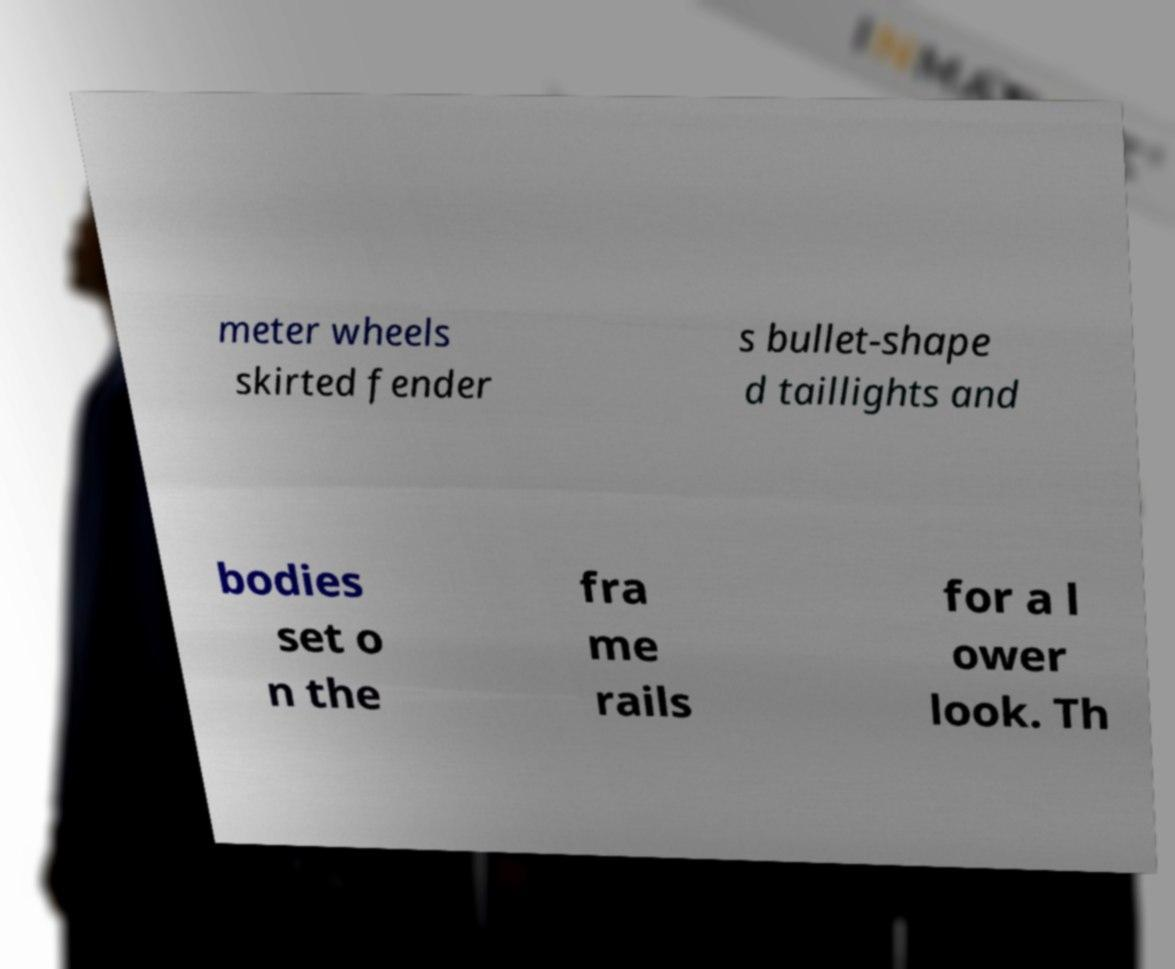Can you read and provide the text displayed in the image?This photo seems to have some interesting text. Can you extract and type it out for me? meter wheels skirted fender s bullet-shape d taillights and bodies set o n the fra me rails for a l ower look. Th 